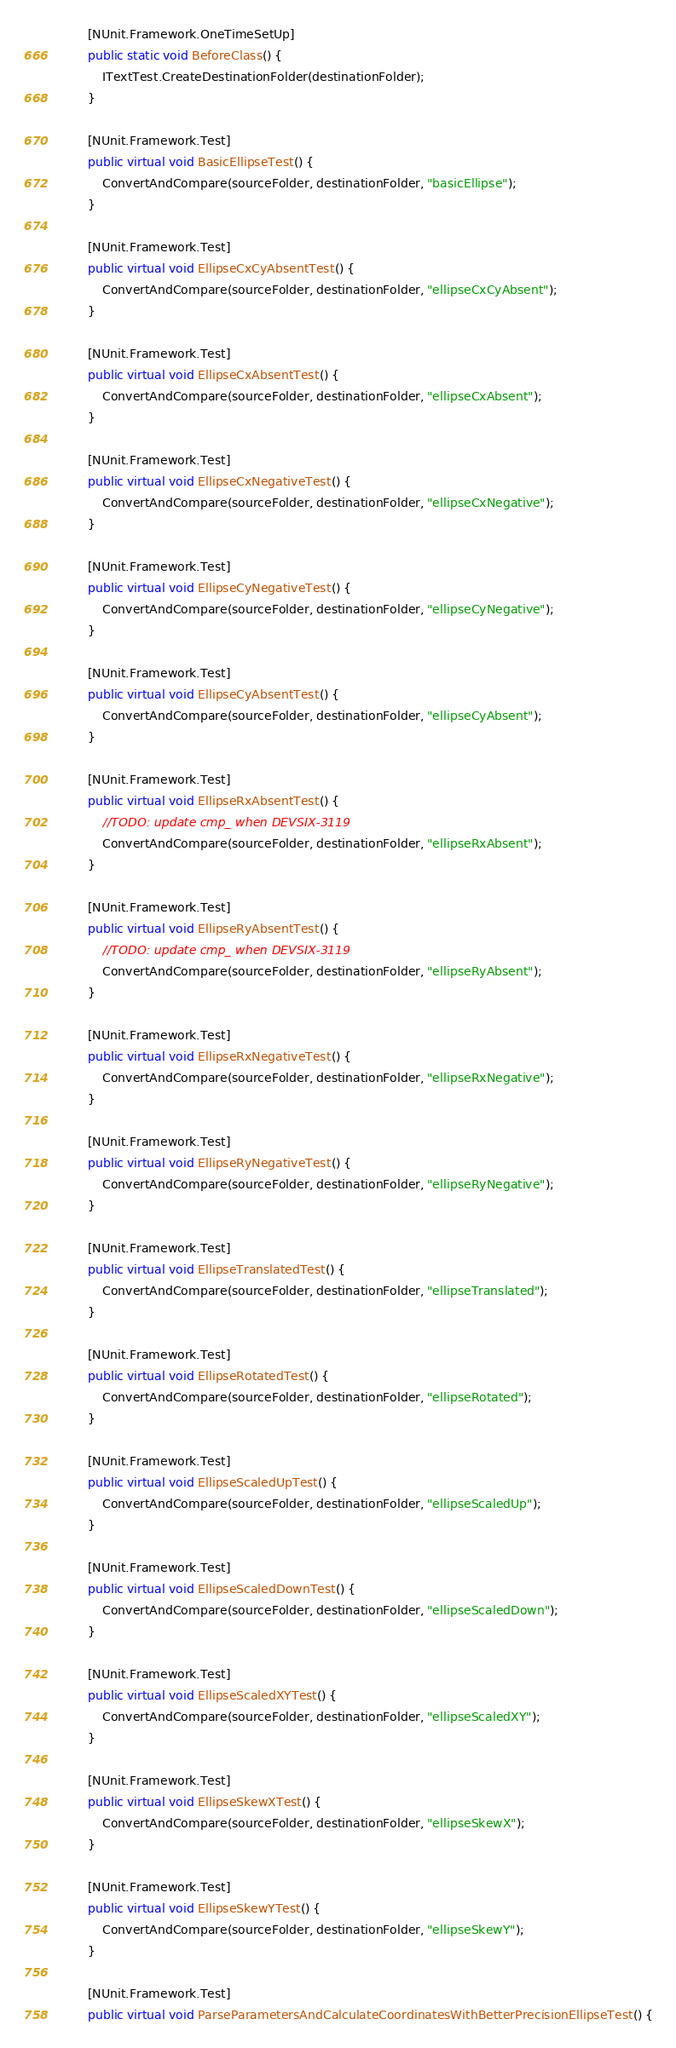Convert code to text. <code><loc_0><loc_0><loc_500><loc_500><_C#_>
        [NUnit.Framework.OneTimeSetUp]
        public static void BeforeClass() {
            ITextTest.CreateDestinationFolder(destinationFolder);
        }

        [NUnit.Framework.Test]
        public virtual void BasicEllipseTest() {
            ConvertAndCompare(sourceFolder, destinationFolder, "basicEllipse");
        }

        [NUnit.Framework.Test]
        public virtual void EllipseCxCyAbsentTest() {
            ConvertAndCompare(sourceFolder, destinationFolder, "ellipseCxCyAbsent");
        }

        [NUnit.Framework.Test]
        public virtual void EllipseCxAbsentTest() {
            ConvertAndCompare(sourceFolder, destinationFolder, "ellipseCxAbsent");
        }

        [NUnit.Framework.Test]
        public virtual void EllipseCxNegativeTest() {
            ConvertAndCompare(sourceFolder, destinationFolder, "ellipseCxNegative");
        }

        [NUnit.Framework.Test]
        public virtual void EllipseCyNegativeTest() {
            ConvertAndCompare(sourceFolder, destinationFolder, "ellipseCyNegative");
        }

        [NUnit.Framework.Test]
        public virtual void EllipseCyAbsentTest() {
            ConvertAndCompare(sourceFolder, destinationFolder, "ellipseCyAbsent");
        }

        [NUnit.Framework.Test]
        public virtual void EllipseRxAbsentTest() {
            //TODO: update cmp_ when DEVSIX-3119
            ConvertAndCompare(sourceFolder, destinationFolder, "ellipseRxAbsent");
        }

        [NUnit.Framework.Test]
        public virtual void EllipseRyAbsentTest() {
            //TODO: update cmp_ when DEVSIX-3119
            ConvertAndCompare(sourceFolder, destinationFolder, "ellipseRyAbsent");
        }

        [NUnit.Framework.Test]
        public virtual void EllipseRxNegativeTest() {
            ConvertAndCompare(sourceFolder, destinationFolder, "ellipseRxNegative");
        }

        [NUnit.Framework.Test]
        public virtual void EllipseRyNegativeTest() {
            ConvertAndCompare(sourceFolder, destinationFolder, "ellipseRyNegative");
        }

        [NUnit.Framework.Test]
        public virtual void EllipseTranslatedTest() {
            ConvertAndCompare(sourceFolder, destinationFolder, "ellipseTranslated");
        }

        [NUnit.Framework.Test]
        public virtual void EllipseRotatedTest() {
            ConvertAndCompare(sourceFolder, destinationFolder, "ellipseRotated");
        }

        [NUnit.Framework.Test]
        public virtual void EllipseScaledUpTest() {
            ConvertAndCompare(sourceFolder, destinationFolder, "ellipseScaledUp");
        }

        [NUnit.Framework.Test]
        public virtual void EllipseScaledDownTest() {
            ConvertAndCompare(sourceFolder, destinationFolder, "ellipseScaledDown");
        }

        [NUnit.Framework.Test]
        public virtual void EllipseScaledXYTest() {
            ConvertAndCompare(sourceFolder, destinationFolder, "ellipseScaledXY");
        }

        [NUnit.Framework.Test]
        public virtual void EllipseSkewXTest() {
            ConvertAndCompare(sourceFolder, destinationFolder, "ellipseSkewX");
        }

        [NUnit.Framework.Test]
        public virtual void EllipseSkewYTest() {
            ConvertAndCompare(sourceFolder, destinationFolder, "ellipseSkewY");
        }

        [NUnit.Framework.Test]
        public virtual void ParseParametersAndCalculateCoordinatesWithBetterPrecisionEllipseTest() {</code> 